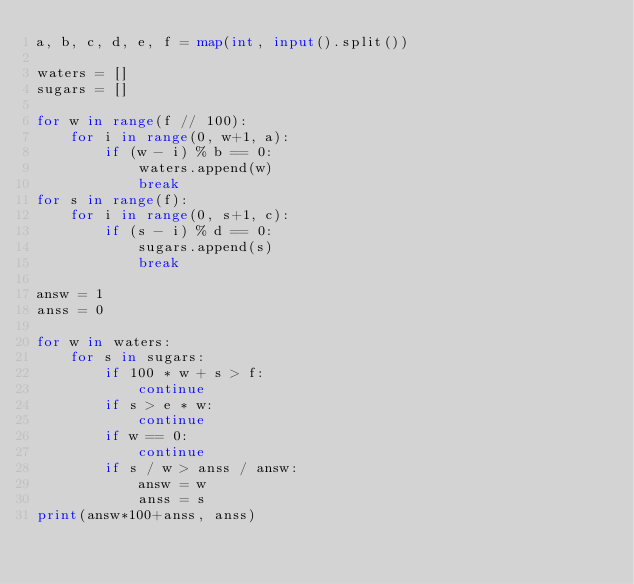<code> <loc_0><loc_0><loc_500><loc_500><_Python_>a, b, c, d, e, f = map(int, input().split())

waters = []
sugars = []

for w in range(f // 100):
    for i in range(0, w+1, a):
        if (w - i) % b == 0:
            waters.append(w)
            break
for s in range(f):
    for i in range(0, s+1, c):
        if (s - i) % d == 0:
            sugars.append(s)
            break

answ = 1
anss = 0

for w in waters:
    for s in sugars:
        if 100 * w + s > f:
            continue
        if s > e * w:
            continue
        if w == 0:
            continue
        if s / w > anss / answ:
            answ = w
            anss = s
print(answ*100+anss, anss)
</code> 